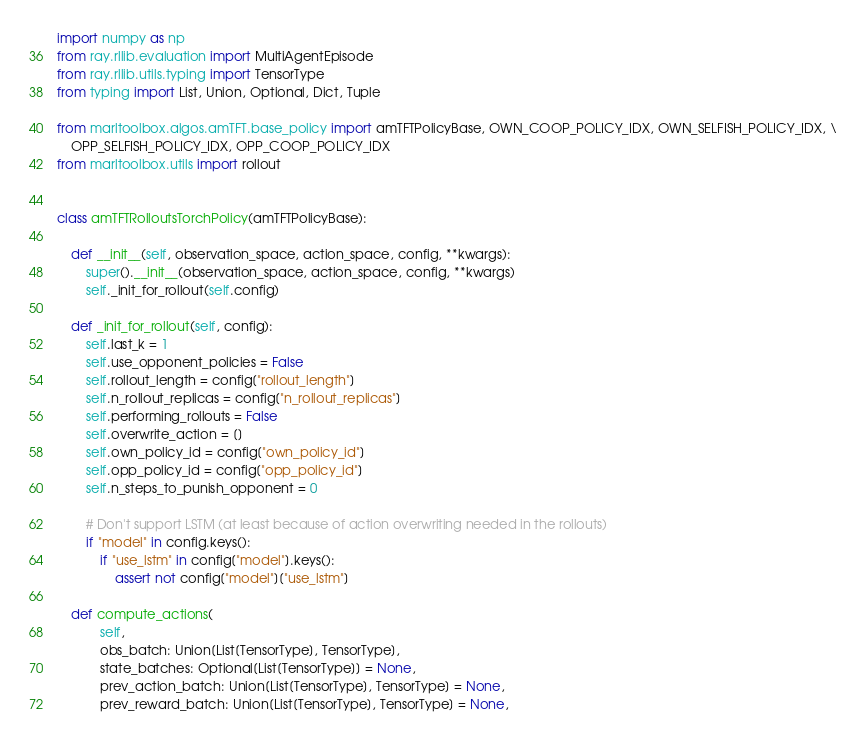Convert code to text. <code><loc_0><loc_0><loc_500><loc_500><_Python_>import numpy as np
from ray.rllib.evaluation import MultiAgentEpisode
from ray.rllib.utils.typing import TensorType
from typing import List, Union, Optional, Dict, Tuple

from marltoolbox.algos.amTFT.base_policy import amTFTPolicyBase, OWN_COOP_POLICY_IDX, OWN_SELFISH_POLICY_IDX, \
    OPP_SELFISH_POLICY_IDX, OPP_COOP_POLICY_IDX
from marltoolbox.utils import rollout


class amTFTRolloutsTorchPolicy(amTFTPolicyBase):

    def __init__(self, observation_space, action_space, config, **kwargs):
        super().__init__(observation_space, action_space, config, **kwargs)
        self._init_for_rollout(self.config)

    def _init_for_rollout(self, config):
        self.last_k = 1
        self.use_opponent_policies = False
        self.rollout_length = config["rollout_length"]
        self.n_rollout_replicas = config["n_rollout_replicas"]
        self.performing_rollouts = False
        self.overwrite_action = []
        self.own_policy_id = config["own_policy_id"]
        self.opp_policy_id = config["opp_policy_id"]
        self.n_steps_to_punish_opponent = 0

        # Don't support LSTM (at least because of action overwriting needed in the rollouts)
        if "model" in config.keys():
            if "use_lstm" in config["model"].keys():
                assert not config["model"]["use_lstm"]

    def compute_actions(
            self,
            obs_batch: Union[List[TensorType], TensorType],
            state_batches: Optional[List[TensorType]] = None,
            prev_action_batch: Union[List[TensorType], TensorType] = None,
            prev_reward_batch: Union[List[TensorType], TensorType] = None,</code> 